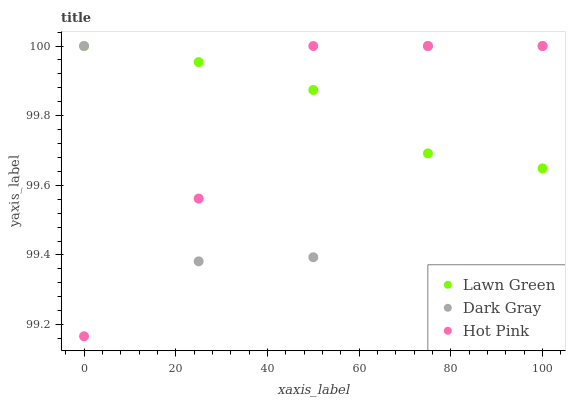Does Dark Gray have the minimum area under the curve?
Answer yes or no. Yes. Does Lawn Green have the maximum area under the curve?
Answer yes or no. Yes. Does Hot Pink have the minimum area under the curve?
Answer yes or no. No. Does Hot Pink have the maximum area under the curve?
Answer yes or no. No. Is Lawn Green the smoothest?
Answer yes or no. Yes. Is Dark Gray the roughest?
Answer yes or no. Yes. Is Hot Pink the smoothest?
Answer yes or no. No. Is Hot Pink the roughest?
Answer yes or no. No. Does Hot Pink have the lowest value?
Answer yes or no. Yes. Does Lawn Green have the lowest value?
Answer yes or no. No. Does Hot Pink have the highest value?
Answer yes or no. Yes. Does Dark Gray intersect Hot Pink?
Answer yes or no. Yes. Is Dark Gray less than Hot Pink?
Answer yes or no. No. Is Dark Gray greater than Hot Pink?
Answer yes or no. No. 